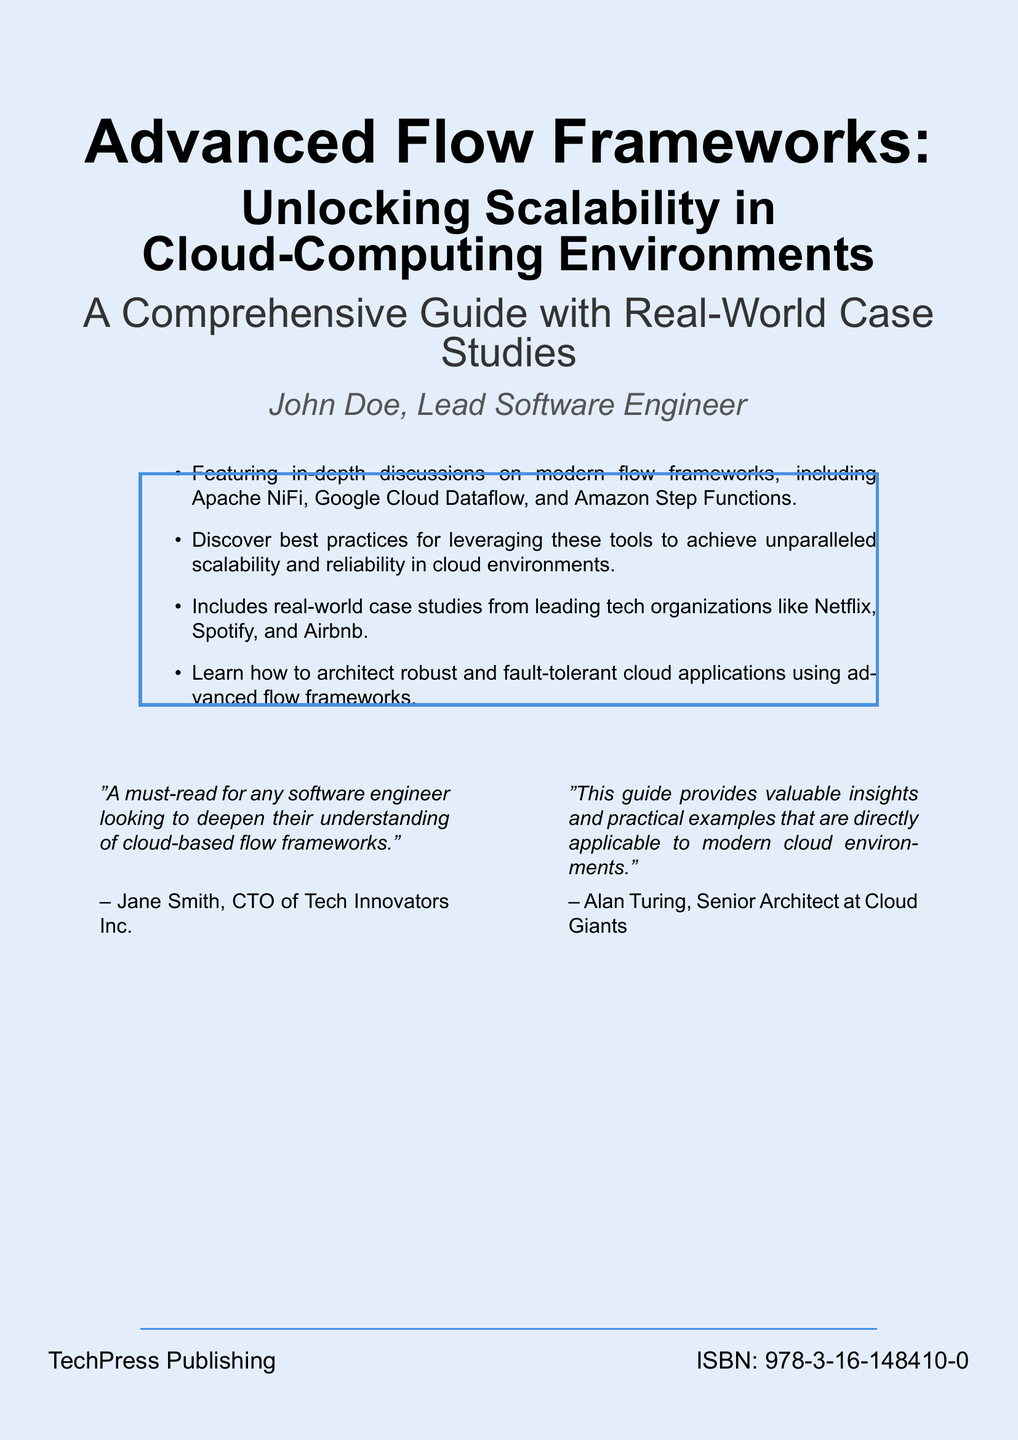What is the title of the book? The title of the book is explicitly stated at the top of the cover.
Answer: Advanced Flow Frameworks Who is the author? The author name is clearly listed below the title of the book.
Answer: John Doe What is the ISBN number? The ISBN number is provided at the bottom of the cover for identification purposes.
Answer: 978-3-16-148410-0 Which company published the book? The publishing company is mentioned towards the end of the cover.
Answer: TechPress Publishing What are some of the flow frameworks discussed in the book? The book cover lists specific flow frameworks that are central to its discussions.
Answer: Apache NiFi, Google Cloud Dataflow, Amazon Step Functions What type of insights does the book provide? The book cover highlights the type of insights the reader can expect.
Answer: Valuable insights and practical examples How many case studies are included in the book? The cover mentions the inclusion of real-world case studies from tech organizations.
Answer: Several case studies Who recommends the book? The cover includes endorsements from notable industry professionals.
Answer: Jane Smith, Alan Turing What is the focus of the book? The focus of the book is indicated through the subtitle and descriptions.
Answer: Scalability in Cloud-Computing Environments 